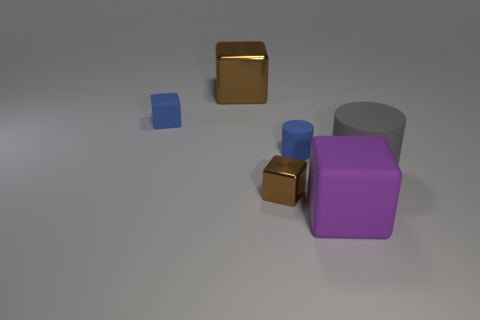Subtract all blue matte blocks. How many blocks are left? 3 Subtract all blue cylinders. How many cylinders are left? 1 Subtract all green balls. How many brown blocks are left? 2 Add 3 gray matte objects. How many objects exist? 9 Subtract all cylinders. How many objects are left? 4 Subtract 2 blocks. How many blocks are left? 2 Add 2 tiny metallic things. How many tiny metallic things are left? 3 Add 1 purple matte objects. How many purple matte objects exist? 2 Subtract 0 cyan spheres. How many objects are left? 6 Subtract all blue cubes. Subtract all cyan balls. How many cubes are left? 3 